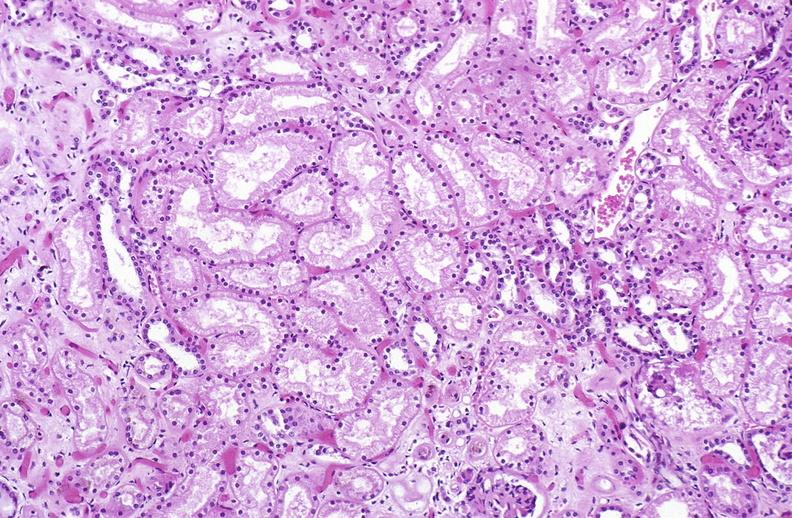s urinary present?
Answer the question using a single word or phrase. Yes 